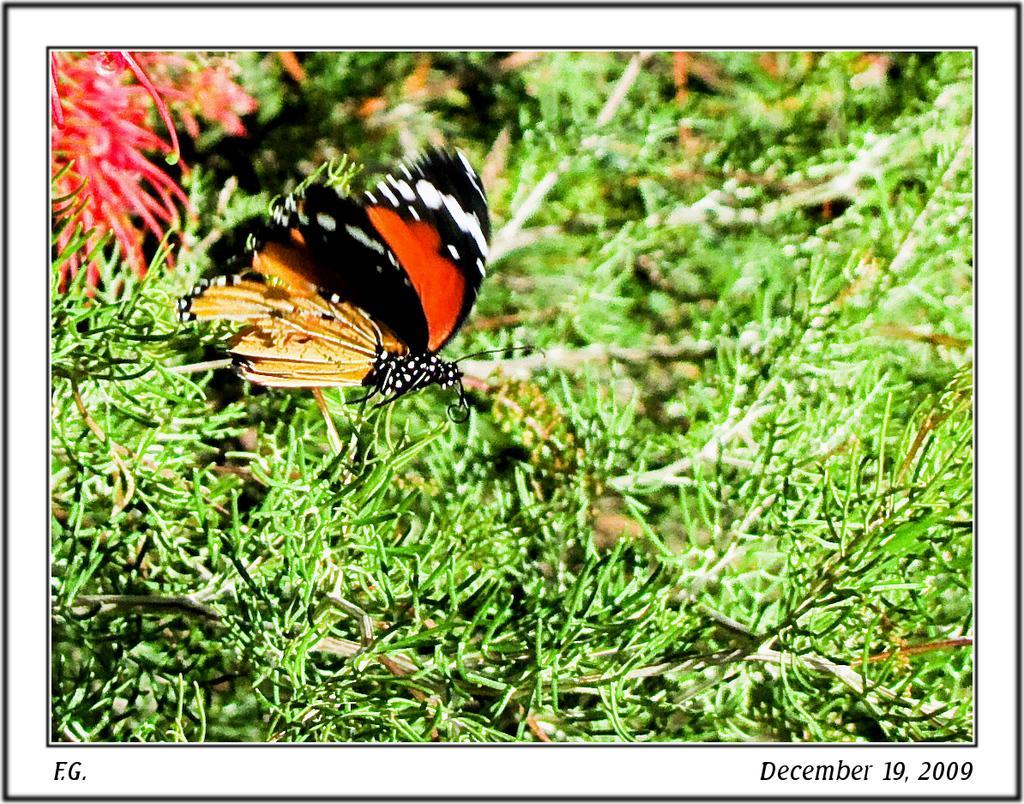Could you give a brief overview of what you see in this image? In this picture we can see a butterfly, flower and leaves are present. 